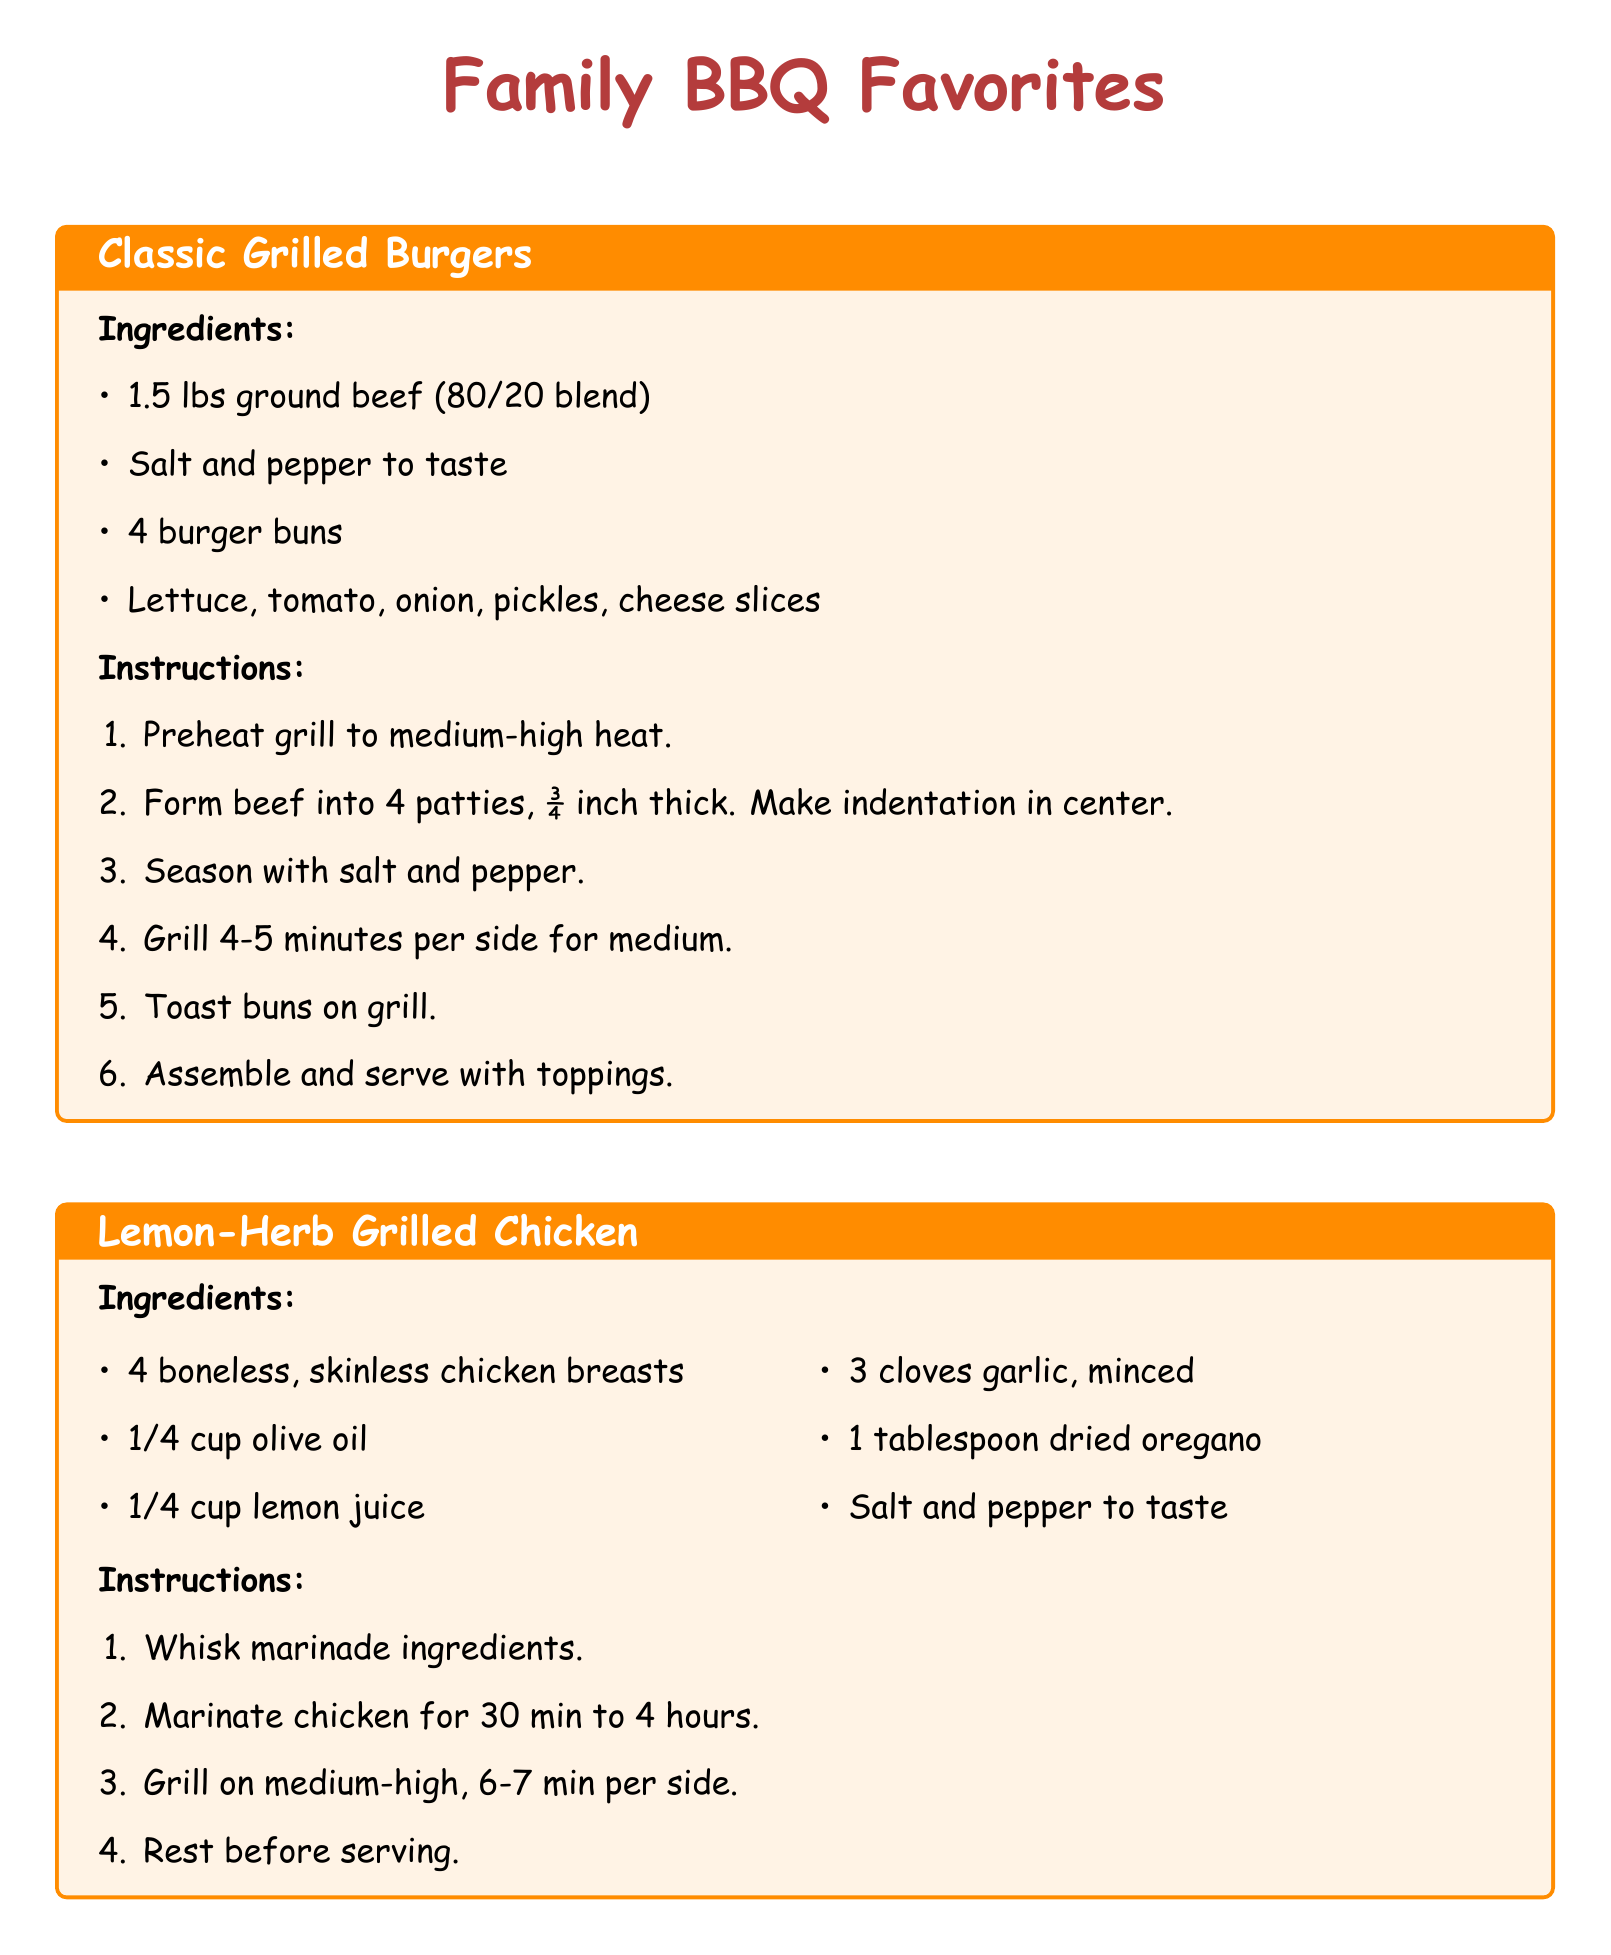What is the weight of ground beef used in the burger recipe? The weight of the ground beef used in the burger recipe is stated as 1.5 lbs.
Answer: 1.5 lbs How long do you grill the burgers for medium doneness? The grilling time for the burgers to achieve medium doneness is specified as 4-5 minutes per side.
Answer: 4-5 minutes per side What is the main ingredient for the Lemon-Herb Grilled Chicken? The main ingredient for the Lemon-Herb Grilled Chicken is boneless, skinless chicken breasts.
Answer: chicken breasts How many cloves of garlic are needed for the chicken marinade? The recipe states that 3 cloves of garlic are needed for the marinade.
Answer: 3 cloves What is brushed on the corn before grilling? The document indicates that butter is brushed on the corn before grilling.
Answer: butter How long should the chicken marinate? The marination time for the chicken is specified as ranging from 30 minutes to 4 hours.
Answer: 30 minutes to 4 hours What should you do to the burger buns before serving? The instructions include toasting the buns on the grill before serving.
Answer: Toast on grill How many ears of corn are needed for the BBQ Grilled Corn on the Cob recipe? The number of ears of corn required is given as 4.
Answer: 4 ears What can be served with the grilled corn if desired? The document mentions that extra butter can be served with the grilled corn if desired.
Answer: extra butter 